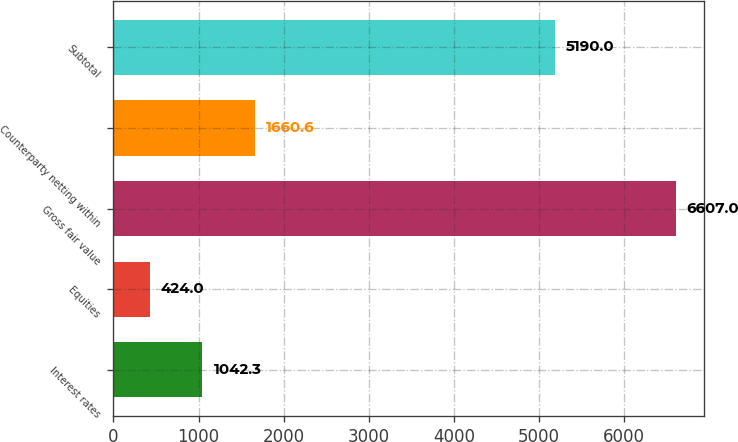Convert chart to OTSL. <chart><loc_0><loc_0><loc_500><loc_500><bar_chart><fcel>Interest rates<fcel>Equities<fcel>Gross fair value<fcel>Counterparty netting within<fcel>Subtotal<nl><fcel>1042.3<fcel>424<fcel>6607<fcel>1660.6<fcel>5190<nl></chart> 